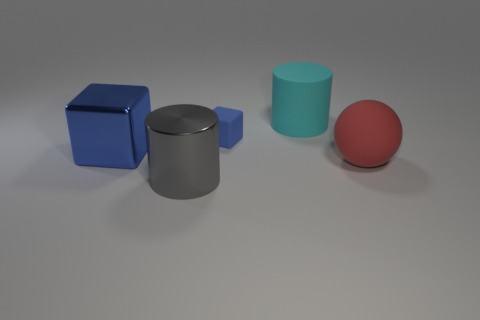Are there any other things that are the same shape as the red matte thing?
Give a very brief answer. No. What color is the big shiny thing in front of the cube that is in front of the rubber block that is to the left of the red ball?
Ensure brevity in your answer.  Gray. What shape is the big object that is left of the big cyan matte object and to the right of the large blue metal cube?
Your response must be concise. Cylinder. Are there any other things that are the same size as the gray cylinder?
Make the answer very short. Yes. What color is the cylinder in front of the cylinder that is behind the red object?
Provide a succinct answer. Gray. What shape is the object that is in front of the object to the right of the big rubber object that is behind the red sphere?
Ensure brevity in your answer.  Cylinder. How big is the object that is both left of the rubber cube and to the right of the big metal block?
Provide a succinct answer. Large. What number of matte cubes have the same color as the big shiny block?
Your answer should be compact. 1. There is another block that is the same color as the matte block; what is it made of?
Offer a very short reply. Metal. What is the large blue object made of?
Make the answer very short. Metal. 